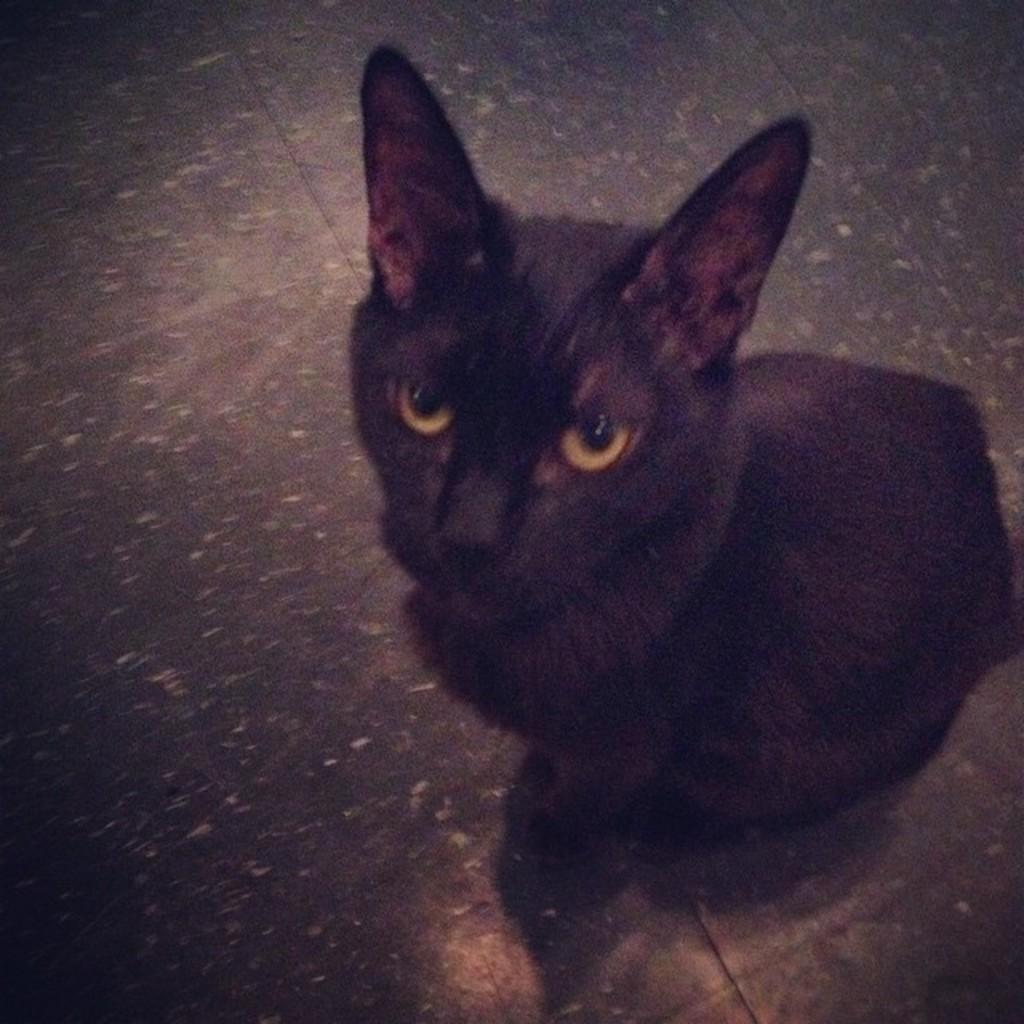What type of animal is in the image? There is a black color cat in the image. Where is the cat located in the image? The cat is seated on the floor. What thought is the cat having while sitting near the mailbox in the image? There is no mailbox present in the image, and therefore no such thought can be attributed to the cat. 